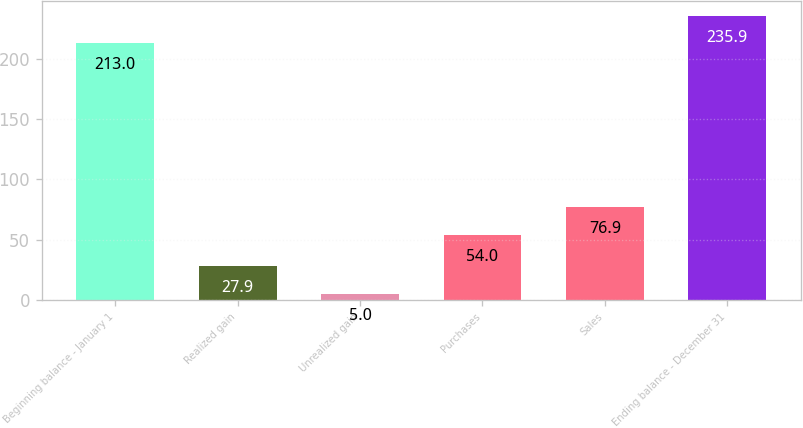Convert chart to OTSL. <chart><loc_0><loc_0><loc_500><loc_500><bar_chart><fcel>Beginning balance - January 1<fcel>Realized gain<fcel>Unrealized gain<fcel>Purchases<fcel>Sales<fcel>Ending balance - December 31<nl><fcel>213<fcel>27.9<fcel>5<fcel>54<fcel>76.9<fcel>235.9<nl></chart> 